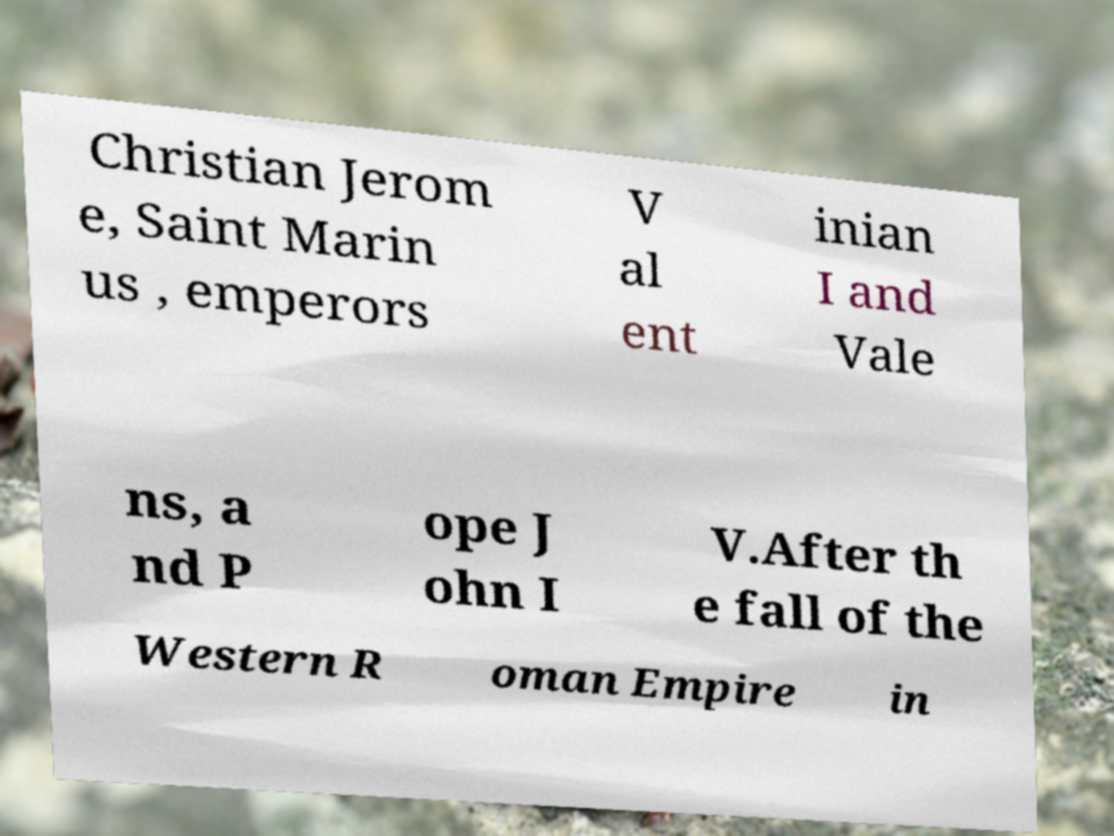I need the written content from this picture converted into text. Can you do that? Christian Jerom e, Saint Marin us , emperors V al ent inian I and Vale ns, a nd P ope J ohn I V.After th e fall of the Western R oman Empire in 